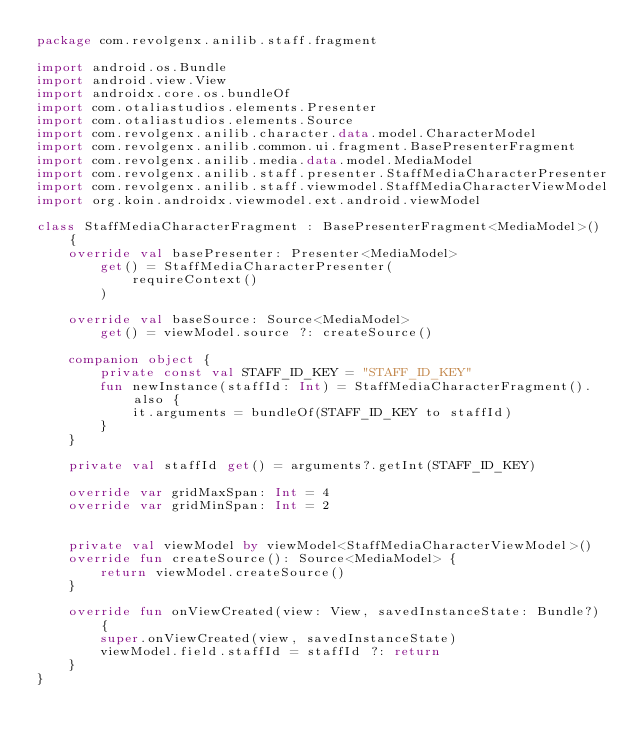Convert code to text. <code><loc_0><loc_0><loc_500><loc_500><_Kotlin_>package com.revolgenx.anilib.staff.fragment

import android.os.Bundle
import android.view.View
import androidx.core.os.bundleOf
import com.otaliastudios.elements.Presenter
import com.otaliastudios.elements.Source
import com.revolgenx.anilib.character.data.model.CharacterModel
import com.revolgenx.anilib.common.ui.fragment.BasePresenterFragment
import com.revolgenx.anilib.media.data.model.MediaModel
import com.revolgenx.anilib.staff.presenter.StaffMediaCharacterPresenter
import com.revolgenx.anilib.staff.viewmodel.StaffMediaCharacterViewModel
import org.koin.androidx.viewmodel.ext.android.viewModel

class StaffMediaCharacterFragment : BasePresenterFragment<MediaModel>() {
    override val basePresenter: Presenter<MediaModel>
        get() = StaffMediaCharacterPresenter(
            requireContext()
        )

    override val baseSource: Source<MediaModel>
        get() = viewModel.source ?: createSource()

    companion object {
        private const val STAFF_ID_KEY = "STAFF_ID_KEY"
        fun newInstance(staffId: Int) = StaffMediaCharacterFragment().also {
            it.arguments = bundleOf(STAFF_ID_KEY to staffId)
        }
    }

    private val staffId get() = arguments?.getInt(STAFF_ID_KEY)

    override var gridMaxSpan: Int = 4
    override var gridMinSpan: Int = 2


    private val viewModel by viewModel<StaffMediaCharacterViewModel>()
    override fun createSource(): Source<MediaModel> {
        return viewModel.createSource()
    }

    override fun onViewCreated(view: View, savedInstanceState: Bundle?) {
        super.onViewCreated(view, savedInstanceState)
        viewModel.field.staffId = staffId ?: return
    }
}</code> 